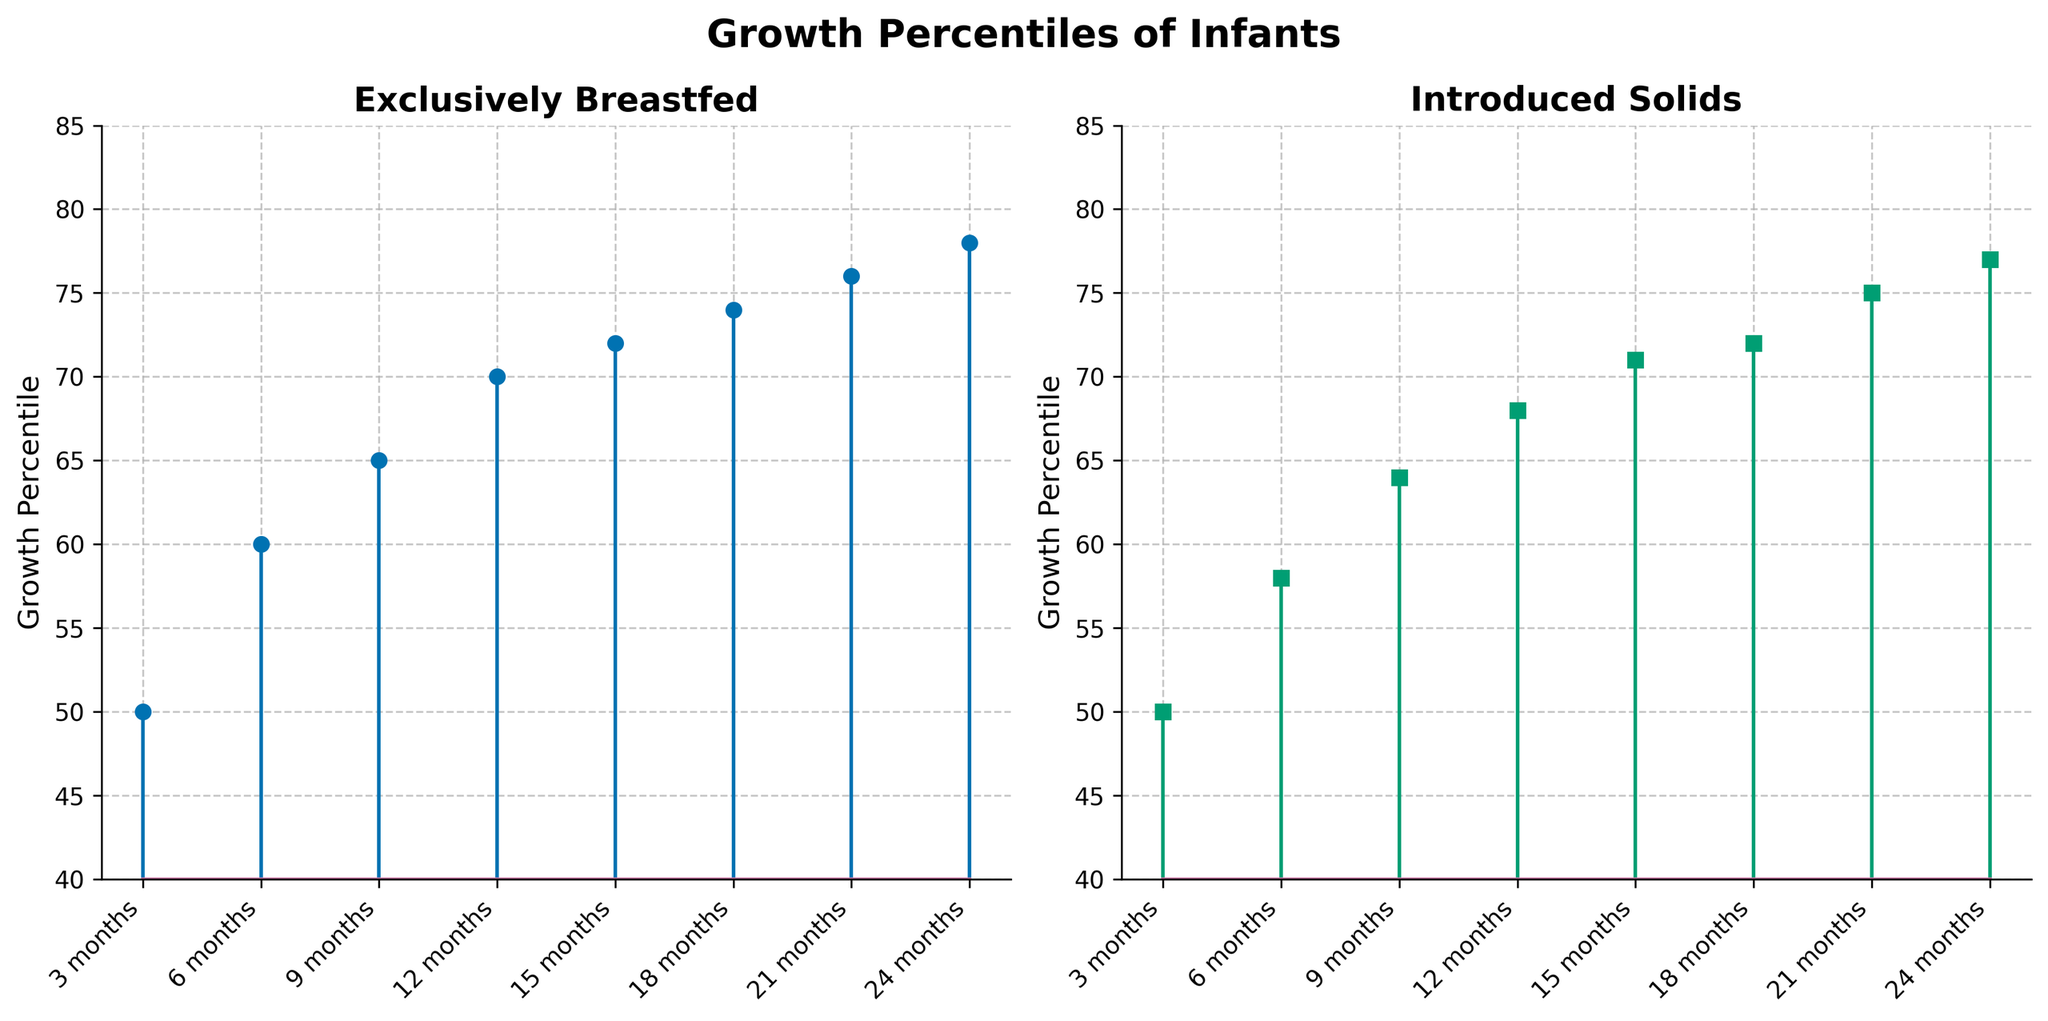What is the title of the left subplot? The title for the left subplot is given at the top of the subplot on the left side.
Answer: Exclusively Breastfed What is the range of the y-axis in both subplots? The range of the y-axis can be observed from the numerical values on the y-axis, starting from the base value to the highest value shown.
Answer: 40 to 85 Which dataset shows a higher growth percentile at 9 months? By examining the heights of the stem markers at 9 months in both subplots, we can compare the growth percentiles.
Answer: Exclusively Breastfed At what age do the infants introduced to solids have the closest growth percentile to those exclusively breastfed? Look at the growth percentiles at each age and identify where the difference between the two percentiles is minimal.
Answer: 15 months Is there a noticeable trend in the growth percentiles for both groups over time? By observing the progression of the stem markers from the leftmost to the rightmost point in each subplot, we can detect the overall trend.
Answer: Yes, both groups show an increasing trend over time How much higher is the growth percentile for exclusively breastfed infants at 24 months compared to those introduced to solids? Subtract the growth percentile of introduced solids from the exclusively breastfed at 24 months to find the difference.
Answer: 1 What is the average growth percentile for exclusively breastfed infants over the entire period? Sum all the growth percentiles for exclusively breastfed and divide by the number of data points to find the average.
Answer: 68.13 How do the growth percentiles of infants at 18 months compare between exclusively breastfed and introduced solids? Compare the values at 18 months directly from both subplots.
Answer: Exclusively Breastfed: 74, Introduced Solids: 72 By what age does the growth percentile of infants introduced to solids exceed 70? Identify the age at which the growth percentile crosses 70 by inspecting the data points in the right subplot.
Answer: 15 months 